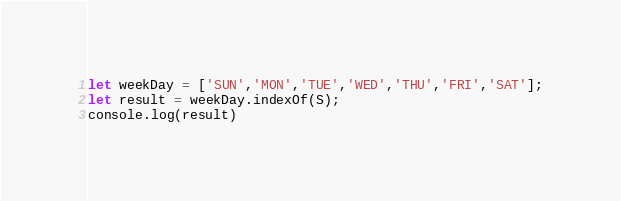<code> <loc_0><loc_0><loc_500><loc_500><_JavaScript_>let weekDay = ['SUN','MON','TUE','WED','THU','FRI','SAT'];
let result = weekDay.indexOf(S);
console.log(result)</code> 